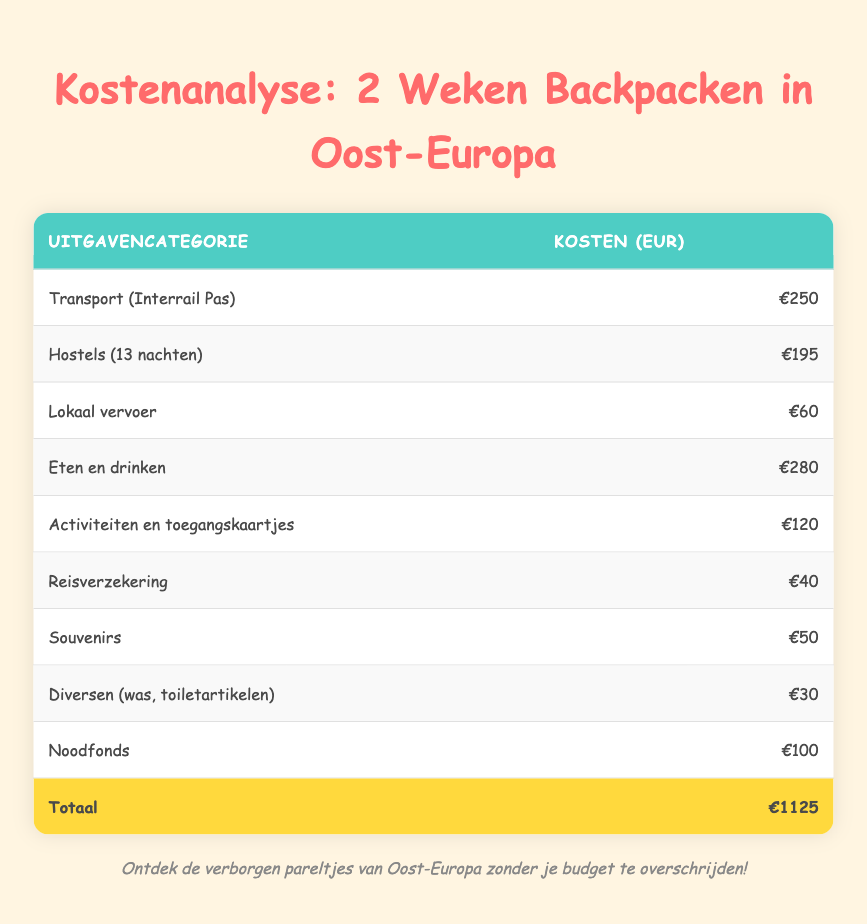What is the cost of the transportation (Interrail Pass)? The table specifies the cost of the transportation (Interrail Pass) under the category "Transportation (Interrail Pass)", which shows a cost of €250.
Answer: 250 How much did you spend on food and drinks? The cost for "Food and drinks" in the table is listed as €280.
Answer: 280 What is the total cost of the trip? The last row of the table clearly states that the total cost of the trip is €1125.
Answer: 1125 What is the difference in cost between hostels and local transportation? To find the difference, we subtract the cost of "Local transportation" (€60) from "Hostels (13 nights)" (€195). The calculation is €195 - €60 = €135.
Answer: 135 Is the cost of travel insurance more than the cost of souvenirs? The cost of travel insurance is €40 and the cost of souvenirs is €50. Since €40 is not greater than €50, the statement is false.
Answer: No If you combine the costs of activities and entrance fees with miscellaneous expenses, what is the total? The cost for "Activities and entrance fees" is €120, and "Miscellaneous (laundry, toiletries)" costs €30. Adding these amounts gives us €120 + €30 = €150.
Answer: 150 What is the average cost of accommodation per night if hostels cost €195 for 13 nights? To find the average cost per night, divide the total cost for hostels (€195) by the number of nights (13). The calculation is €195 / 13 = €15.00.
Answer: 15 How much more did you spend on food and drinks than on travel insurance? The cost of food and drinks is €280, and travel insurance costs €40. The difference is €280 - €40 = €240.
Answer: 240 Does the total cost of miscellaneous expenses exceed the cost of local transportation? The table shows that miscellaneous expenses total €30 and local transportation costs €60. Since €30 is not greater than €60, the statement is false.
Answer: No 